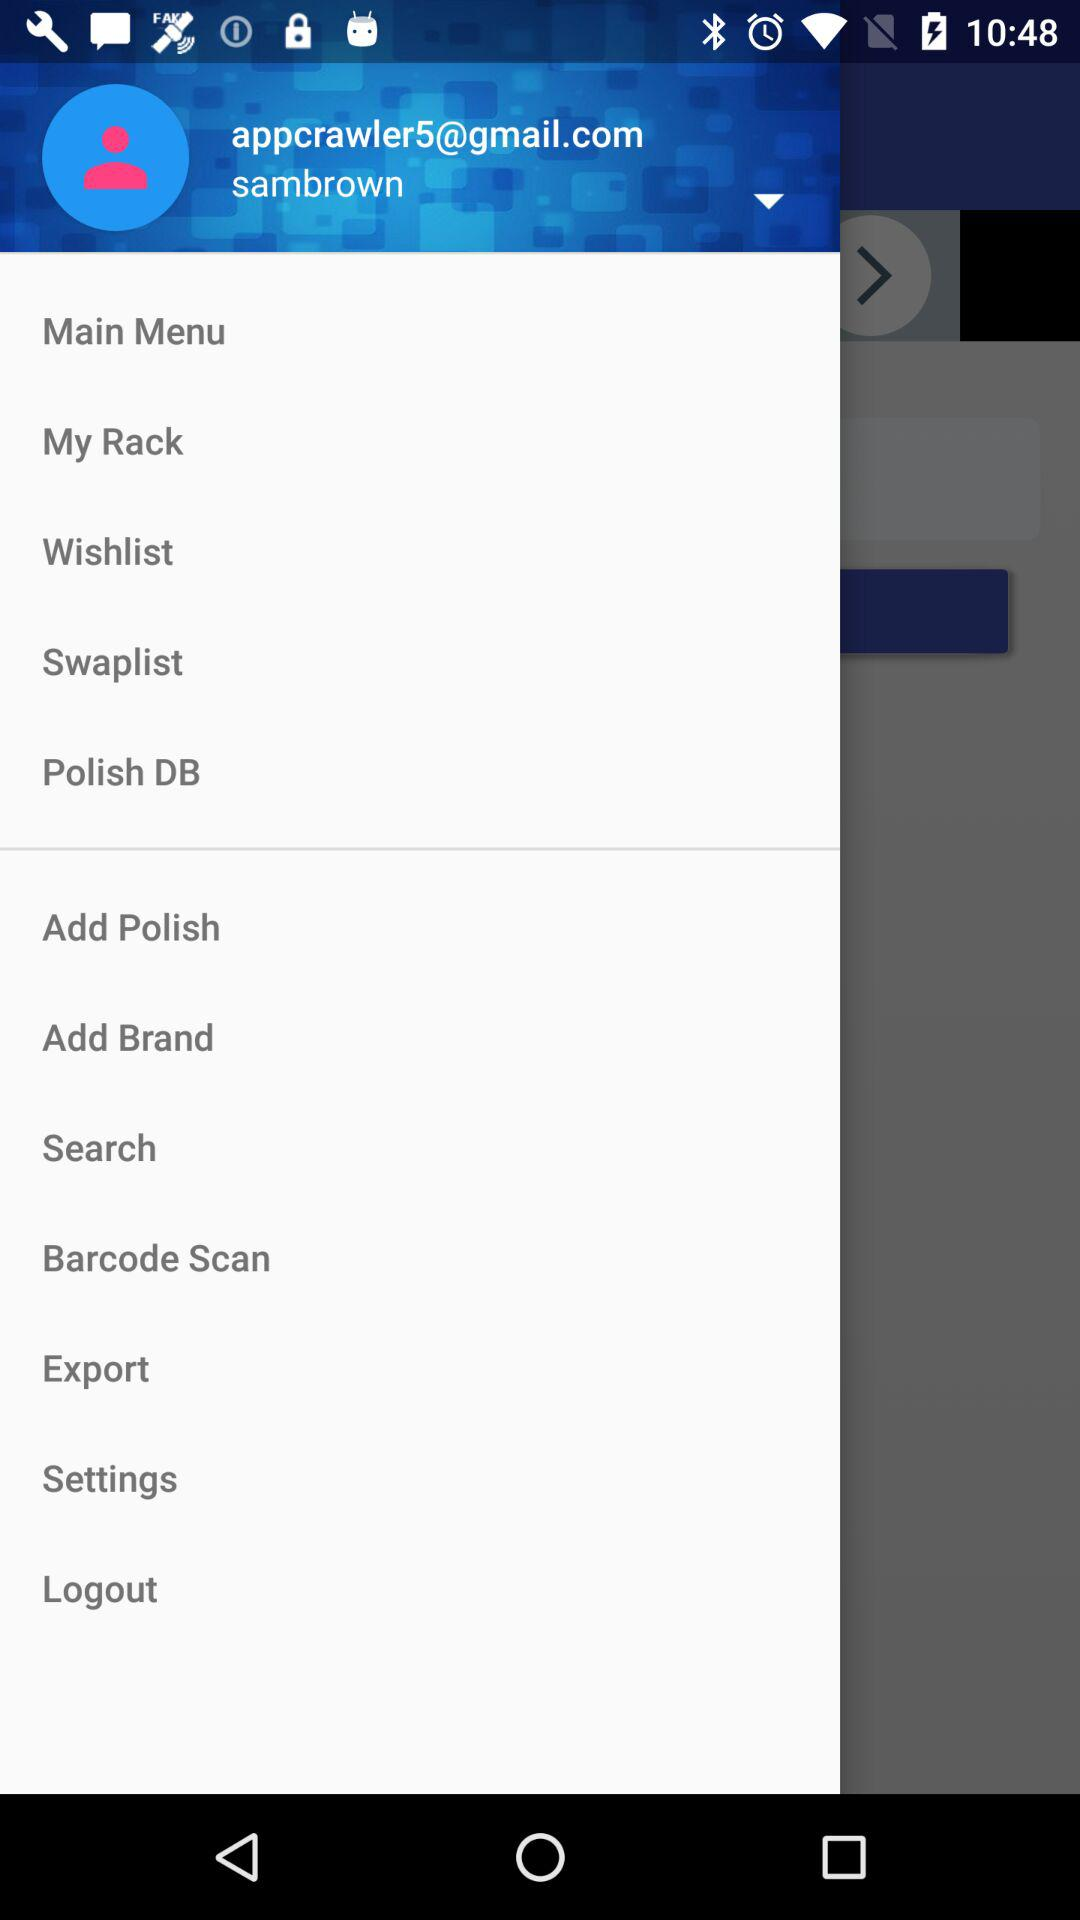What Gmail account address is used there? The used Gmail account address is appcrawler5@gmail.com. 